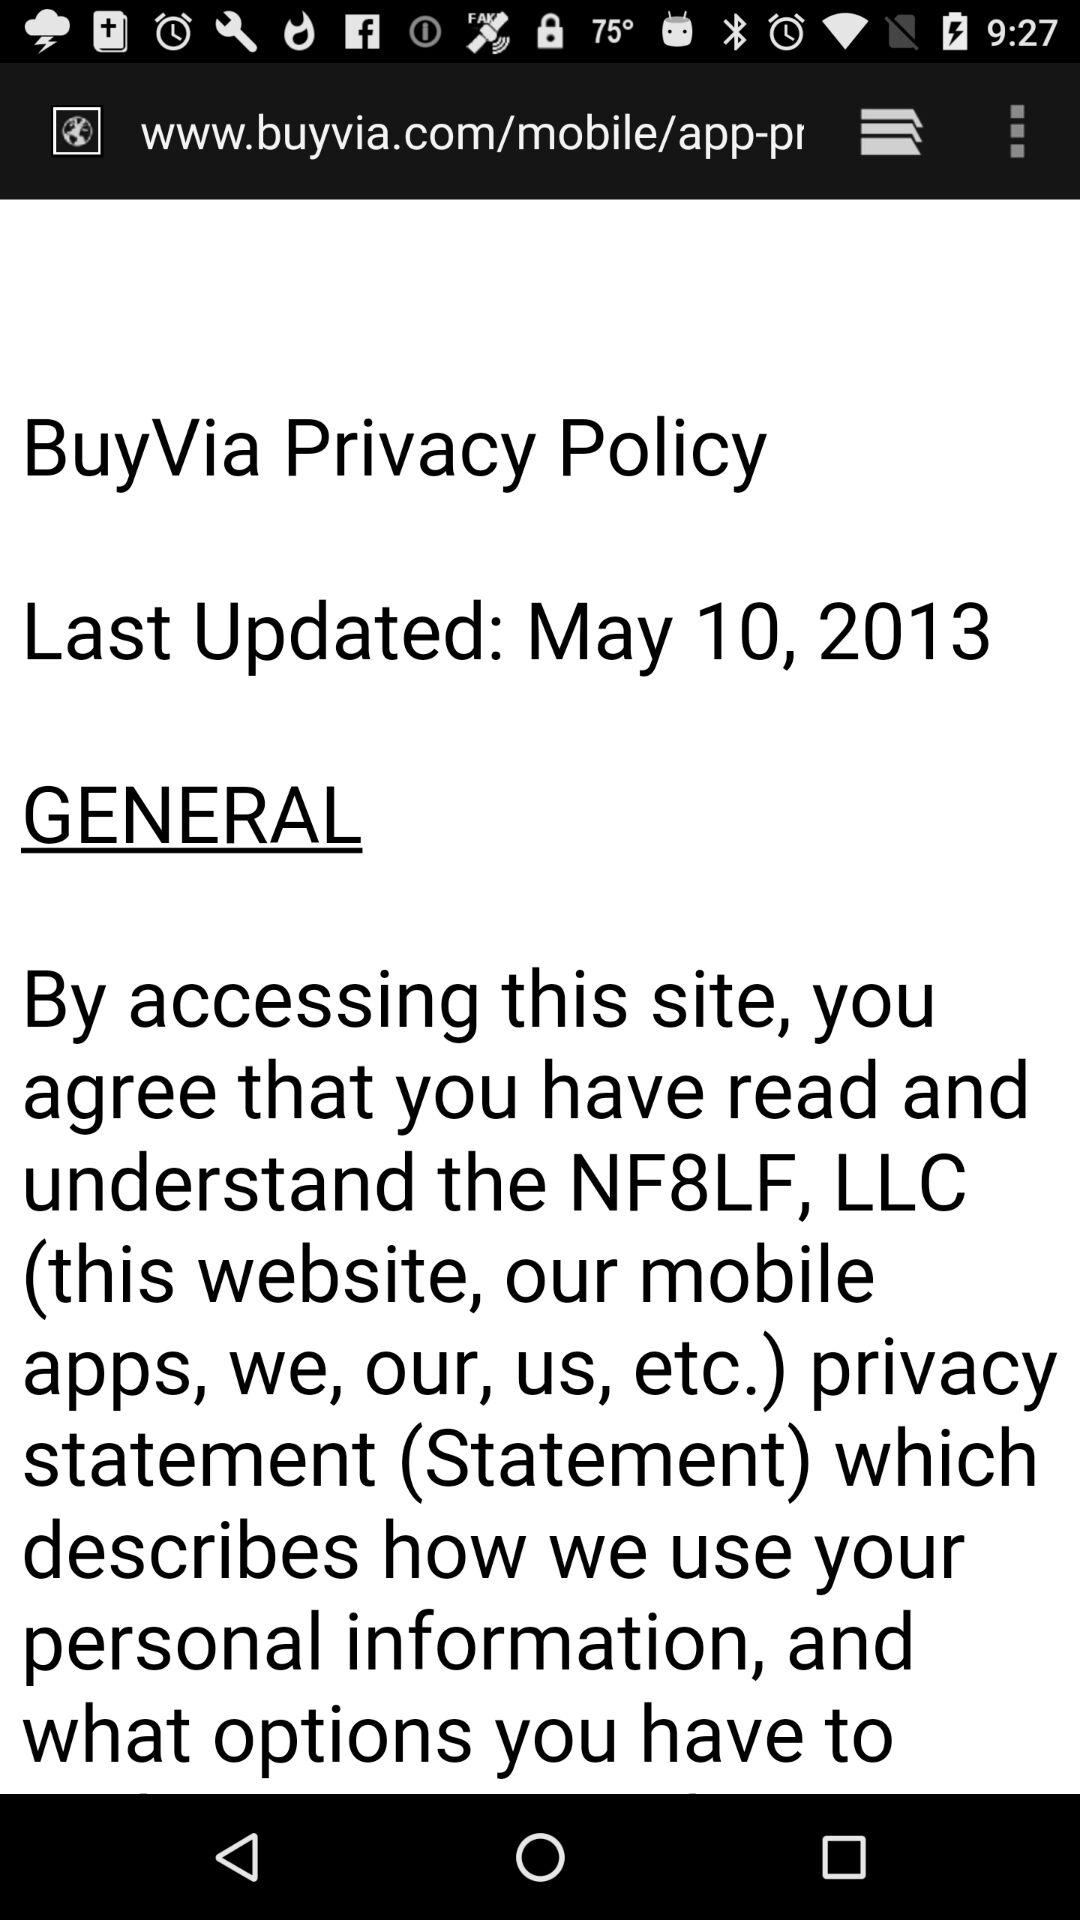What is the email address?
When the provided information is insufficient, respond with <no answer>. <no answer> 